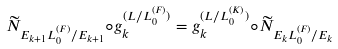<formula> <loc_0><loc_0><loc_500><loc_500>\widetilde { N } _ { E _ { k + 1 } L _ { 0 } ^ { ( F ) } / E _ { k + 1 } } \circ g _ { k } ^ { ( L / L _ { 0 } ^ { ( F ) } ) } = g _ { k } ^ { ( L / L _ { 0 } ^ { ( K ) } ) } \circ \widetilde { N } _ { E _ { k } L _ { 0 } ^ { ( F ) } / E _ { k } }</formula> 